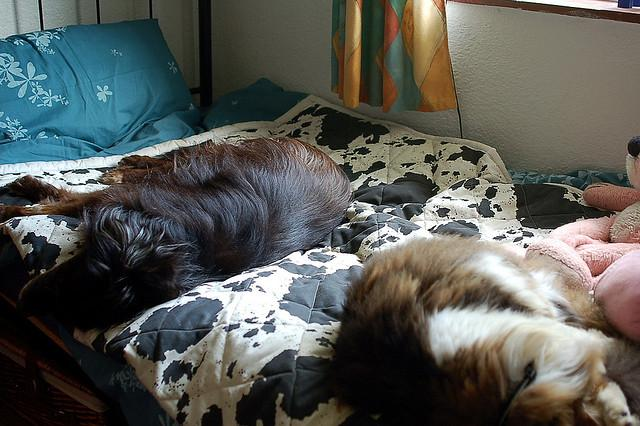Who is the bed for? Please explain your reasoning. human. This bed is for humans. 